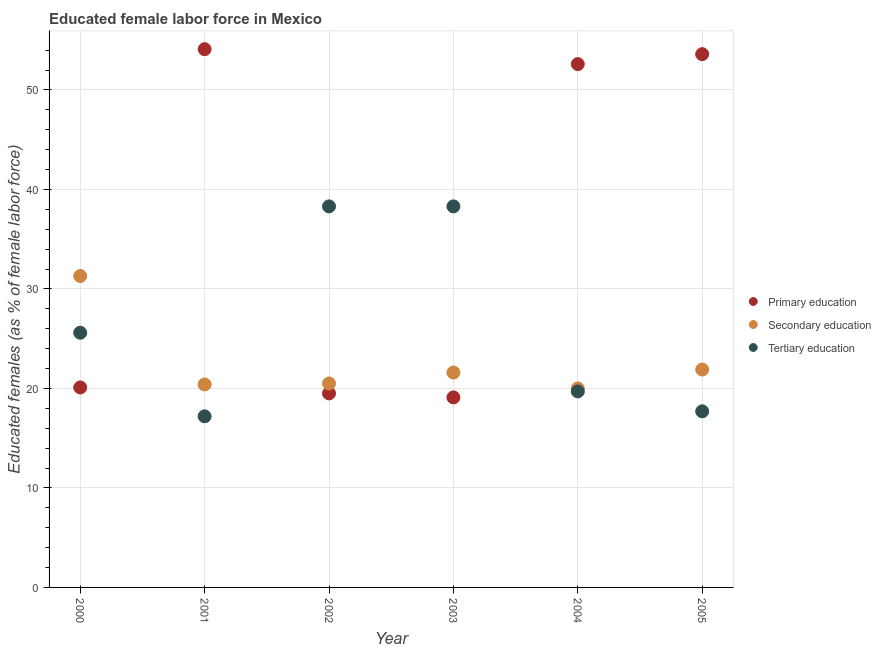How many different coloured dotlines are there?
Provide a succinct answer. 3. Is the number of dotlines equal to the number of legend labels?
Make the answer very short. Yes. What is the percentage of female labor force who received secondary education in 2000?
Provide a succinct answer. 31.3. Across all years, what is the maximum percentage of female labor force who received primary education?
Give a very brief answer. 54.1. Across all years, what is the minimum percentage of female labor force who received tertiary education?
Offer a very short reply. 17.2. What is the total percentage of female labor force who received tertiary education in the graph?
Keep it short and to the point. 156.8. What is the difference between the percentage of female labor force who received secondary education in 2000 and that in 2001?
Give a very brief answer. 10.9. What is the difference between the percentage of female labor force who received tertiary education in 2000 and the percentage of female labor force who received primary education in 2004?
Give a very brief answer. -27. What is the average percentage of female labor force who received secondary education per year?
Provide a short and direct response. 22.62. In the year 2005, what is the difference between the percentage of female labor force who received secondary education and percentage of female labor force who received tertiary education?
Provide a succinct answer. 4.2. What is the ratio of the percentage of female labor force who received secondary education in 2002 to that in 2005?
Provide a succinct answer. 0.94. What is the difference between the highest and the second highest percentage of female labor force who received tertiary education?
Your answer should be very brief. 0. What is the difference between the highest and the lowest percentage of female labor force who received tertiary education?
Provide a short and direct response. 21.1. Is it the case that in every year, the sum of the percentage of female labor force who received primary education and percentage of female labor force who received secondary education is greater than the percentage of female labor force who received tertiary education?
Your answer should be very brief. Yes. Does the percentage of female labor force who received primary education monotonically increase over the years?
Make the answer very short. No. Does the graph contain any zero values?
Provide a succinct answer. No. Does the graph contain grids?
Your response must be concise. Yes. How many legend labels are there?
Offer a terse response. 3. What is the title of the graph?
Offer a very short reply. Educated female labor force in Mexico. What is the label or title of the Y-axis?
Ensure brevity in your answer.  Educated females (as % of female labor force). What is the Educated females (as % of female labor force) of Primary education in 2000?
Provide a succinct answer. 20.1. What is the Educated females (as % of female labor force) in Secondary education in 2000?
Your response must be concise. 31.3. What is the Educated females (as % of female labor force) of Tertiary education in 2000?
Keep it short and to the point. 25.6. What is the Educated females (as % of female labor force) in Primary education in 2001?
Offer a very short reply. 54.1. What is the Educated females (as % of female labor force) of Secondary education in 2001?
Provide a succinct answer. 20.4. What is the Educated females (as % of female labor force) of Tertiary education in 2001?
Keep it short and to the point. 17.2. What is the Educated females (as % of female labor force) in Primary education in 2002?
Your response must be concise. 19.5. What is the Educated females (as % of female labor force) in Secondary education in 2002?
Make the answer very short. 20.5. What is the Educated females (as % of female labor force) of Tertiary education in 2002?
Provide a succinct answer. 38.3. What is the Educated females (as % of female labor force) of Primary education in 2003?
Provide a succinct answer. 19.1. What is the Educated females (as % of female labor force) of Secondary education in 2003?
Your response must be concise. 21.6. What is the Educated females (as % of female labor force) of Tertiary education in 2003?
Your answer should be very brief. 38.3. What is the Educated females (as % of female labor force) of Primary education in 2004?
Provide a short and direct response. 52.6. What is the Educated females (as % of female labor force) in Tertiary education in 2004?
Give a very brief answer. 19.7. What is the Educated females (as % of female labor force) of Primary education in 2005?
Offer a very short reply. 53.6. What is the Educated females (as % of female labor force) of Secondary education in 2005?
Ensure brevity in your answer.  21.9. What is the Educated females (as % of female labor force) of Tertiary education in 2005?
Provide a succinct answer. 17.7. Across all years, what is the maximum Educated females (as % of female labor force) of Primary education?
Offer a very short reply. 54.1. Across all years, what is the maximum Educated females (as % of female labor force) of Secondary education?
Offer a terse response. 31.3. Across all years, what is the maximum Educated females (as % of female labor force) in Tertiary education?
Make the answer very short. 38.3. Across all years, what is the minimum Educated females (as % of female labor force) in Primary education?
Keep it short and to the point. 19.1. Across all years, what is the minimum Educated females (as % of female labor force) in Secondary education?
Your response must be concise. 20. Across all years, what is the minimum Educated females (as % of female labor force) in Tertiary education?
Offer a very short reply. 17.2. What is the total Educated females (as % of female labor force) in Primary education in the graph?
Ensure brevity in your answer.  219. What is the total Educated females (as % of female labor force) of Secondary education in the graph?
Your answer should be compact. 135.7. What is the total Educated females (as % of female labor force) in Tertiary education in the graph?
Your response must be concise. 156.8. What is the difference between the Educated females (as % of female labor force) of Primary education in 2000 and that in 2001?
Your answer should be compact. -34. What is the difference between the Educated females (as % of female labor force) in Secondary education in 2000 and that in 2001?
Provide a succinct answer. 10.9. What is the difference between the Educated females (as % of female labor force) in Tertiary education in 2000 and that in 2001?
Provide a succinct answer. 8.4. What is the difference between the Educated females (as % of female labor force) in Primary education in 2000 and that in 2002?
Keep it short and to the point. 0.6. What is the difference between the Educated females (as % of female labor force) of Secondary education in 2000 and that in 2002?
Your answer should be very brief. 10.8. What is the difference between the Educated females (as % of female labor force) in Primary education in 2000 and that in 2003?
Your answer should be very brief. 1. What is the difference between the Educated females (as % of female labor force) in Primary education in 2000 and that in 2004?
Offer a very short reply. -32.5. What is the difference between the Educated females (as % of female labor force) in Secondary education in 2000 and that in 2004?
Make the answer very short. 11.3. What is the difference between the Educated females (as % of female labor force) in Tertiary education in 2000 and that in 2004?
Make the answer very short. 5.9. What is the difference between the Educated females (as % of female labor force) of Primary education in 2000 and that in 2005?
Ensure brevity in your answer.  -33.5. What is the difference between the Educated females (as % of female labor force) of Secondary education in 2000 and that in 2005?
Offer a terse response. 9.4. What is the difference between the Educated females (as % of female labor force) in Tertiary education in 2000 and that in 2005?
Your answer should be compact. 7.9. What is the difference between the Educated females (as % of female labor force) of Primary education in 2001 and that in 2002?
Your answer should be compact. 34.6. What is the difference between the Educated females (as % of female labor force) of Tertiary education in 2001 and that in 2002?
Keep it short and to the point. -21.1. What is the difference between the Educated females (as % of female labor force) of Primary education in 2001 and that in 2003?
Provide a succinct answer. 35. What is the difference between the Educated females (as % of female labor force) in Tertiary education in 2001 and that in 2003?
Provide a short and direct response. -21.1. What is the difference between the Educated females (as % of female labor force) of Tertiary education in 2001 and that in 2004?
Give a very brief answer. -2.5. What is the difference between the Educated females (as % of female labor force) of Primary education in 2001 and that in 2005?
Your answer should be very brief. 0.5. What is the difference between the Educated females (as % of female labor force) in Secondary education in 2001 and that in 2005?
Make the answer very short. -1.5. What is the difference between the Educated females (as % of female labor force) of Primary education in 2002 and that in 2003?
Offer a very short reply. 0.4. What is the difference between the Educated females (as % of female labor force) of Secondary education in 2002 and that in 2003?
Make the answer very short. -1.1. What is the difference between the Educated females (as % of female labor force) in Primary education in 2002 and that in 2004?
Keep it short and to the point. -33.1. What is the difference between the Educated females (as % of female labor force) in Secondary education in 2002 and that in 2004?
Provide a short and direct response. 0.5. What is the difference between the Educated females (as % of female labor force) in Primary education in 2002 and that in 2005?
Your answer should be compact. -34.1. What is the difference between the Educated females (as % of female labor force) in Secondary education in 2002 and that in 2005?
Keep it short and to the point. -1.4. What is the difference between the Educated females (as % of female labor force) of Tertiary education in 2002 and that in 2005?
Ensure brevity in your answer.  20.6. What is the difference between the Educated females (as % of female labor force) in Primary education in 2003 and that in 2004?
Your response must be concise. -33.5. What is the difference between the Educated females (as % of female labor force) of Secondary education in 2003 and that in 2004?
Provide a succinct answer. 1.6. What is the difference between the Educated females (as % of female labor force) of Tertiary education in 2003 and that in 2004?
Offer a very short reply. 18.6. What is the difference between the Educated females (as % of female labor force) of Primary education in 2003 and that in 2005?
Provide a short and direct response. -34.5. What is the difference between the Educated females (as % of female labor force) in Secondary education in 2003 and that in 2005?
Ensure brevity in your answer.  -0.3. What is the difference between the Educated females (as % of female labor force) of Tertiary education in 2003 and that in 2005?
Your answer should be very brief. 20.6. What is the difference between the Educated females (as % of female labor force) in Secondary education in 2004 and that in 2005?
Keep it short and to the point. -1.9. What is the difference between the Educated females (as % of female labor force) in Primary education in 2000 and the Educated females (as % of female labor force) in Secondary education in 2001?
Provide a succinct answer. -0.3. What is the difference between the Educated females (as % of female labor force) of Primary education in 2000 and the Educated females (as % of female labor force) of Tertiary education in 2002?
Give a very brief answer. -18.2. What is the difference between the Educated females (as % of female labor force) of Primary education in 2000 and the Educated females (as % of female labor force) of Tertiary education in 2003?
Give a very brief answer. -18.2. What is the difference between the Educated females (as % of female labor force) in Secondary education in 2000 and the Educated females (as % of female labor force) in Tertiary education in 2003?
Ensure brevity in your answer.  -7. What is the difference between the Educated females (as % of female labor force) of Primary education in 2000 and the Educated females (as % of female labor force) of Secondary education in 2004?
Ensure brevity in your answer.  0.1. What is the difference between the Educated females (as % of female labor force) in Secondary education in 2000 and the Educated females (as % of female labor force) in Tertiary education in 2004?
Your answer should be very brief. 11.6. What is the difference between the Educated females (as % of female labor force) of Primary education in 2000 and the Educated females (as % of female labor force) of Tertiary education in 2005?
Give a very brief answer. 2.4. What is the difference between the Educated females (as % of female labor force) of Primary education in 2001 and the Educated females (as % of female labor force) of Secondary education in 2002?
Offer a terse response. 33.6. What is the difference between the Educated females (as % of female labor force) in Secondary education in 2001 and the Educated females (as % of female labor force) in Tertiary education in 2002?
Provide a succinct answer. -17.9. What is the difference between the Educated females (as % of female labor force) of Primary education in 2001 and the Educated females (as % of female labor force) of Secondary education in 2003?
Your answer should be compact. 32.5. What is the difference between the Educated females (as % of female labor force) of Primary education in 2001 and the Educated females (as % of female labor force) of Tertiary education in 2003?
Your response must be concise. 15.8. What is the difference between the Educated females (as % of female labor force) in Secondary education in 2001 and the Educated females (as % of female labor force) in Tertiary education in 2003?
Offer a terse response. -17.9. What is the difference between the Educated females (as % of female labor force) of Primary education in 2001 and the Educated females (as % of female labor force) of Secondary education in 2004?
Ensure brevity in your answer.  34.1. What is the difference between the Educated females (as % of female labor force) of Primary education in 2001 and the Educated females (as % of female labor force) of Tertiary education in 2004?
Offer a very short reply. 34.4. What is the difference between the Educated females (as % of female labor force) in Secondary education in 2001 and the Educated females (as % of female labor force) in Tertiary education in 2004?
Ensure brevity in your answer.  0.7. What is the difference between the Educated females (as % of female labor force) of Primary education in 2001 and the Educated females (as % of female labor force) of Secondary education in 2005?
Make the answer very short. 32.2. What is the difference between the Educated females (as % of female labor force) of Primary education in 2001 and the Educated females (as % of female labor force) of Tertiary education in 2005?
Offer a very short reply. 36.4. What is the difference between the Educated females (as % of female labor force) in Primary education in 2002 and the Educated females (as % of female labor force) in Secondary education in 2003?
Give a very brief answer. -2.1. What is the difference between the Educated females (as % of female labor force) in Primary education in 2002 and the Educated females (as % of female labor force) in Tertiary education in 2003?
Provide a short and direct response. -18.8. What is the difference between the Educated females (as % of female labor force) in Secondary education in 2002 and the Educated females (as % of female labor force) in Tertiary education in 2003?
Ensure brevity in your answer.  -17.8. What is the difference between the Educated females (as % of female labor force) of Primary education in 2002 and the Educated females (as % of female labor force) of Tertiary education in 2004?
Keep it short and to the point. -0.2. What is the difference between the Educated females (as % of female labor force) in Secondary education in 2002 and the Educated females (as % of female labor force) in Tertiary education in 2004?
Make the answer very short. 0.8. What is the difference between the Educated females (as % of female labor force) in Primary education in 2003 and the Educated females (as % of female labor force) in Tertiary education in 2004?
Keep it short and to the point. -0.6. What is the difference between the Educated females (as % of female labor force) of Primary education in 2003 and the Educated females (as % of female labor force) of Secondary education in 2005?
Your answer should be compact. -2.8. What is the difference between the Educated females (as % of female labor force) in Primary education in 2003 and the Educated females (as % of female labor force) in Tertiary education in 2005?
Give a very brief answer. 1.4. What is the difference between the Educated females (as % of female labor force) of Secondary education in 2003 and the Educated females (as % of female labor force) of Tertiary education in 2005?
Your response must be concise. 3.9. What is the difference between the Educated females (as % of female labor force) of Primary education in 2004 and the Educated females (as % of female labor force) of Secondary education in 2005?
Your response must be concise. 30.7. What is the difference between the Educated females (as % of female labor force) of Primary education in 2004 and the Educated females (as % of female labor force) of Tertiary education in 2005?
Offer a very short reply. 34.9. What is the average Educated females (as % of female labor force) of Primary education per year?
Offer a very short reply. 36.5. What is the average Educated females (as % of female labor force) in Secondary education per year?
Your answer should be very brief. 22.62. What is the average Educated females (as % of female labor force) in Tertiary education per year?
Give a very brief answer. 26.13. In the year 2000, what is the difference between the Educated females (as % of female labor force) of Secondary education and Educated females (as % of female labor force) of Tertiary education?
Your answer should be very brief. 5.7. In the year 2001, what is the difference between the Educated females (as % of female labor force) in Primary education and Educated females (as % of female labor force) in Secondary education?
Your response must be concise. 33.7. In the year 2001, what is the difference between the Educated females (as % of female labor force) of Primary education and Educated females (as % of female labor force) of Tertiary education?
Ensure brevity in your answer.  36.9. In the year 2002, what is the difference between the Educated females (as % of female labor force) in Primary education and Educated females (as % of female labor force) in Tertiary education?
Keep it short and to the point. -18.8. In the year 2002, what is the difference between the Educated females (as % of female labor force) of Secondary education and Educated females (as % of female labor force) of Tertiary education?
Ensure brevity in your answer.  -17.8. In the year 2003, what is the difference between the Educated females (as % of female labor force) in Primary education and Educated females (as % of female labor force) in Secondary education?
Offer a terse response. -2.5. In the year 2003, what is the difference between the Educated females (as % of female labor force) of Primary education and Educated females (as % of female labor force) of Tertiary education?
Offer a very short reply. -19.2. In the year 2003, what is the difference between the Educated females (as % of female labor force) in Secondary education and Educated females (as % of female labor force) in Tertiary education?
Your answer should be compact. -16.7. In the year 2004, what is the difference between the Educated females (as % of female labor force) in Primary education and Educated females (as % of female labor force) in Secondary education?
Ensure brevity in your answer.  32.6. In the year 2004, what is the difference between the Educated females (as % of female labor force) of Primary education and Educated females (as % of female labor force) of Tertiary education?
Your answer should be compact. 32.9. In the year 2005, what is the difference between the Educated females (as % of female labor force) in Primary education and Educated females (as % of female labor force) in Secondary education?
Ensure brevity in your answer.  31.7. In the year 2005, what is the difference between the Educated females (as % of female labor force) of Primary education and Educated females (as % of female labor force) of Tertiary education?
Make the answer very short. 35.9. In the year 2005, what is the difference between the Educated females (as % of female labor force) of Secondary education and Educated females (as % of female labor force) of Tertiary education?
Give a very brief answer. 4.2. What is the ratio of the Educated females (as % of female labor force) of Primary education in 2000 to that in 2001?
Provide a succinct answer. 0.37. What is the ratio of the Educated females (as % of female labor force) of Secondary education in 2000 to that in 2001?
Ensure brevity in your answer.  1.53. What is the ratio of the Educated females (as % of female labor force) in Tertiary education in 2000 to that in 2001?
Offer a very short reply. 1.49. What is the ratio of the Educated females (as % of female labor force) of Primary education in 2000 to that in 2002?
Ensure brevity in your answer.  1.03. What is the ratio of the Educated females (as % of female labor force) of Secondary education in 2000 to that in 2002?
Your answer should be compact. 1.53. What is the ratio of the Educated females (as % of female labor force) of Tertiary education in 2000 to that in 2002?
Your response must be concise. 0.67. What is the ratio of the Educated females (as % of female labor force) in Primary education in 2000 to that in 2003?
Provide a short and direct response. 1.05. What is the ratio of the Educated females (as % of female labor force) in Secondary education in 2000 to that in 2003?
Your response must be concise. 1.45. What is the ratio of the Educated females (as % of female labor force) in Tertiary education in 2000 to that in 2003?
Keep it short and to the point. 0.67. What is the ratio of the Educated females (as % of female labor force) of Primary education in 2000 to that in 2004?
Give a very brief answer. 0.38. What is the ratio of the Educated females (as % of female labor force) of Secondary education in 2000 to that in 2004?
Offer a very short reply. 1.56. What is the ratio of the Educated females (as % of female labor force) in Tertiary education in 2000 to that in 2004?
Provide a succinct answer. 1.3. What is the ratio of the Educated females (as % of female labor force) of Secondary education in 2000 to that in 2005?
Ensure brevity in your answer.  1.43. What is the ratio of the Educated females (as % of female labor force) in Tertiary education in 2000 to that in 2005?
Provide a succinct answer. 1.45. What is the ratio of the Educated females (as % of female labor force) of Primary education in 2001 to that in 2002?
Keep it short and to the point. 2.77. What is the ratio of the Educated females (as % of female labor force) in Secondary education in 2001 to that in 2002?
Your response must be concise. 1. What is the ratio of the Educated females (as % of female labor force) of Tertiary education in 2001 to that in 2002?
Give a very brief answer. 0.45. What is the ratio of the Educated females (as % of female labor force) of Primary education in 2001 to that in 2003?
Ensure brevity in your answer.  2.83. What is the ratio of the Educated females (as % of female labor force) in Tertiary education in 2001 to that in 2003?
Provide a short and direct response. 0.45. What is the ratio of the Educated females (as % of female labor force) of Primary education in 2001 to that in 2004?
Give a very brief answer. 1.03. What is the ratio of the Educated females (as % of female labor force) in Tertiary education in 2001 to that in 2004?
Your response must be concise. 0.87. What is the ratio of the Educated females (as % of female labor force) of Primary education in 2001 to that in 2005?
Keep it short and to the point. 1.01. What is the ratio of the Educated females (as % of female labor force) in Secondary education in 2001 to that in 2005?
Offer a terse response. 0.93. What is the ratio of the Educated females (as % of female labor force) of Tertiary education in 2001 to that in 2005?
Offer a terse response. 0.97. What is the ratio of the Educated females (as % of female labor force) in Primary education in 2002 to that in 2003?
Ensure brevity in your answer.  1.02. What is the ratio of the Educated females (as % of female labor force) in Secondary education in 2002 to that in 2003?
Offer a terse response. 0.95. What is the ratio of the Educated females (as % of female labor force) of Primary education in 2002 to that in 2004?
Your answer should be compact. 0.37. What is the ratio of the Educated females (as % of female labor force) in Secondary education in 2002 to that in 2004?
Keep it short and to the point. 1.02. What is the ratio of the Educated females (as % of female labor force) of Tertiary education in 2002 to that in 2004?
Ensure brevity in your answer.  1.94. What is the ratio of the Educated females (as % of female labor force) in Primary education in 2002 to that in 2005?
Provide a succinct answer. 0.36. What is the ratio of the Educated females (as % of female labor force) in Secondary education in 2002 to that in 2005?
Give a very brief answer. 0.94. What is the ratio of the Educated females (as % of female labor force) in Tertiary education in 2002 to that in 2005?
Provide a short and direct response. 2.16. What is the ratio of the Educated females (as % of female labor force) of Primary education in 2003 to that in 2004?
Give a very brief answer. 0.36. What is the ratio of the Educated females (as % of female labor force) in Secondary education in 2003 to that in 2004?
Make the answer very short. 1.08. What is the ratio of the Educated females (as % of female labor force) of Tertiary education in 2003 to that in 2004?
Provide a short and direct response. 1.94. What is the ratio of the Educated females (as % of female labor force) in Primary education in 2003 to that in 2005?
Your answer should be very brief. 0.36. What is the ratio of the Educated females (as % of female labor force) in Secondary education in 2003 to that in 2005?
Your answer should be compact. 0.99. What is the ratio of the Educated females (as % of female labor force) in Tertiary education in 2003 to that in 2005?
Provide a short and direct response. 2.16. What is the ratio of the Educated females (as % of female labor force) of Primary education in 2004 to that in 2005?
Offer a very short reply. 0.98. What is the ratio of the Educated females (as % of female labor force) in Secondary education in 2004 to that in 2005?
Offer a terse response. 0.91. What is the ratio of the Educated females (as % of female labor force) in Tertiary education in 2004 to that in 2005?
Your response must be concise. 1.11. What is the difference between the highest and the lowest Educated females (as % of female labor force) in Tertiary education?
Ensure brevity in your answer.  21.1. 